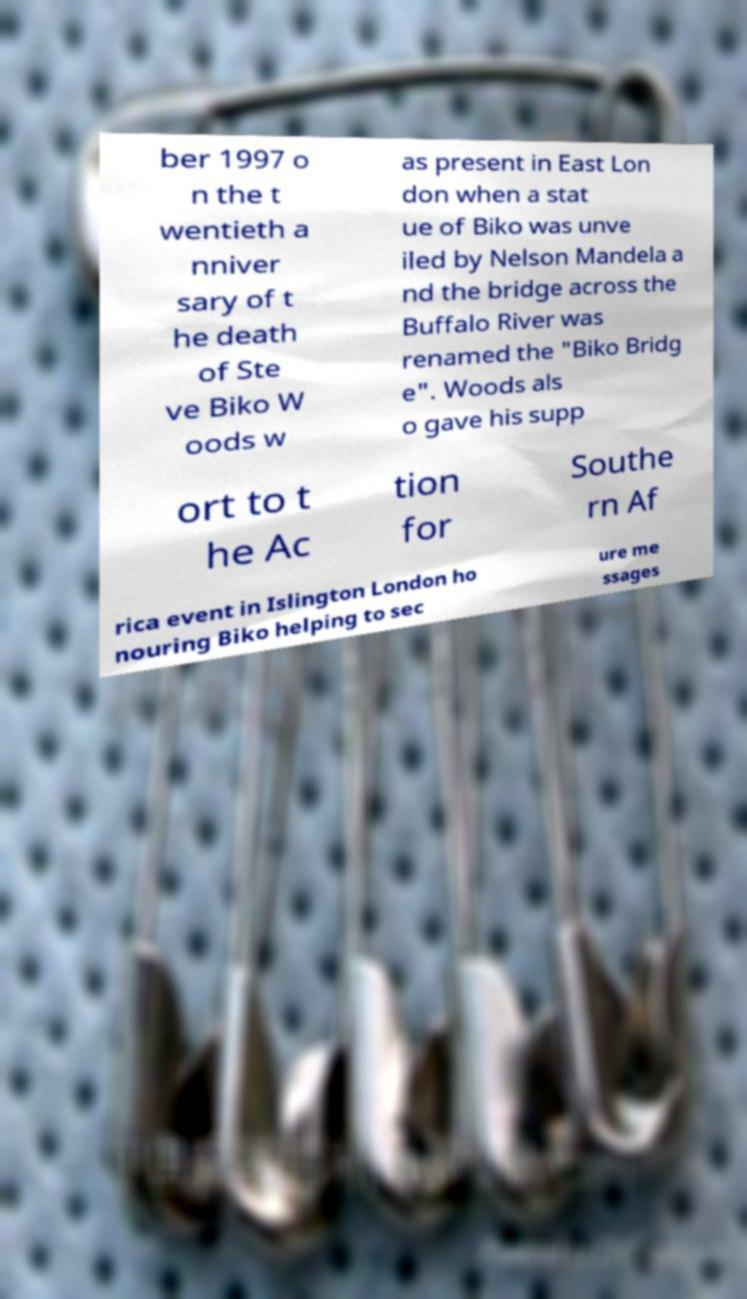Could you extract and type out the text from this image? ber 1997 o n the t wentieth a nniver sary of t he death of Ste ve Biko W oods w as present in East Lon don when a stat ue of Biko was unve iled by Nelson Mandela a nd the bridge across the Buffalo River was renamed the "Biko Bridg e". Woods als o gave his supp ort to t he Ac tion for Southe rn Af rica event in Islington London ho nouring Biko helping to sec ure me ssages 